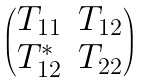<formula> <loc_0><loc_0><loc_500><loc_500>\begin{pmatrix} T _ { 1 1 } & T _ { 1 2 } \\ T _ { 1 2 } ^ { * } & T _ { 2 2 } \end{pmatrix}</formula> 